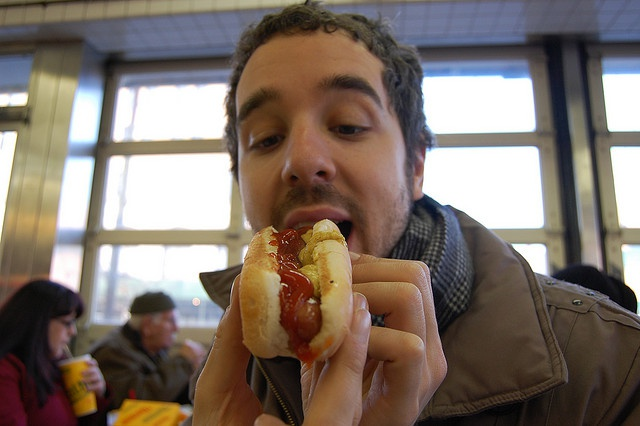Describe the objects in this image and their specific colors. I can see people in gray, black, and maroon tones, hot dog in gray, maroon, olive, and tan tones, people in gray, black, maroon, and brown tones, people in gray, black, and maroon tones, and people in gray and black tones in this image. 